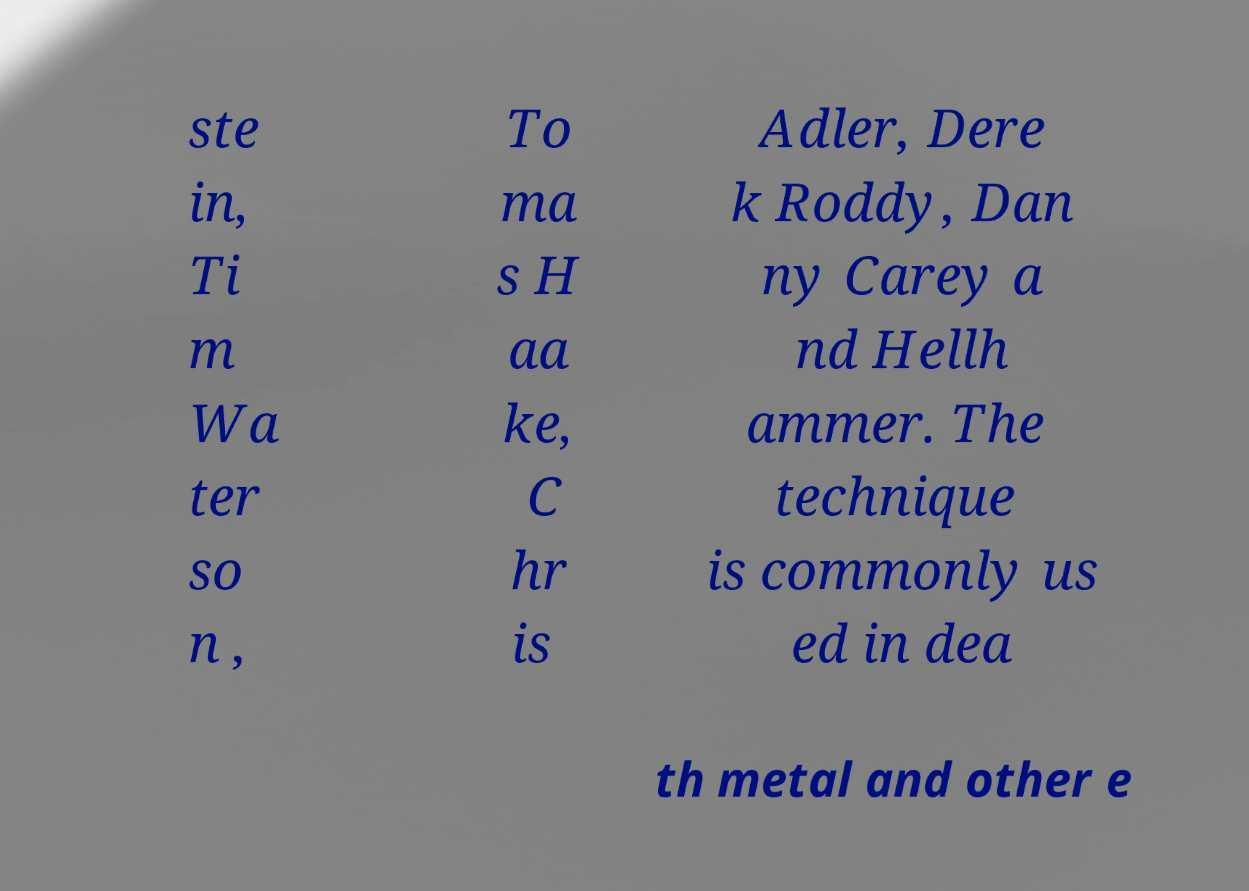Please identify and transcribe the text found in this image. ste in, Ti m Wa ter so n , To ma s H aa ke, C hr is Adler, Dere k Roddy, Dan ny Carey a nd Hellh ammer. The technique is commonly us ed in dea th metal and other e 